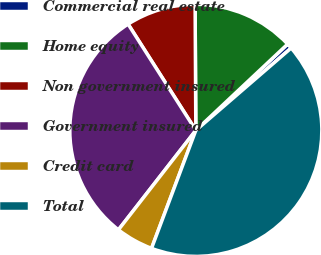Convert chart. <chart><loc_0><loc_0><loc_500><loc_500><pie_chart><fcel>Commercial real estate<fcel>Home equity<fcel>Non government insured<fcel>Government insured<fcel>Credit card<fcel>Total<nl><fcel>0.67%<fcel>13.08%<fcel>8.94%<fcel>30.44%<fcel>4.81%<fcel>42.05%<nl></chart> 